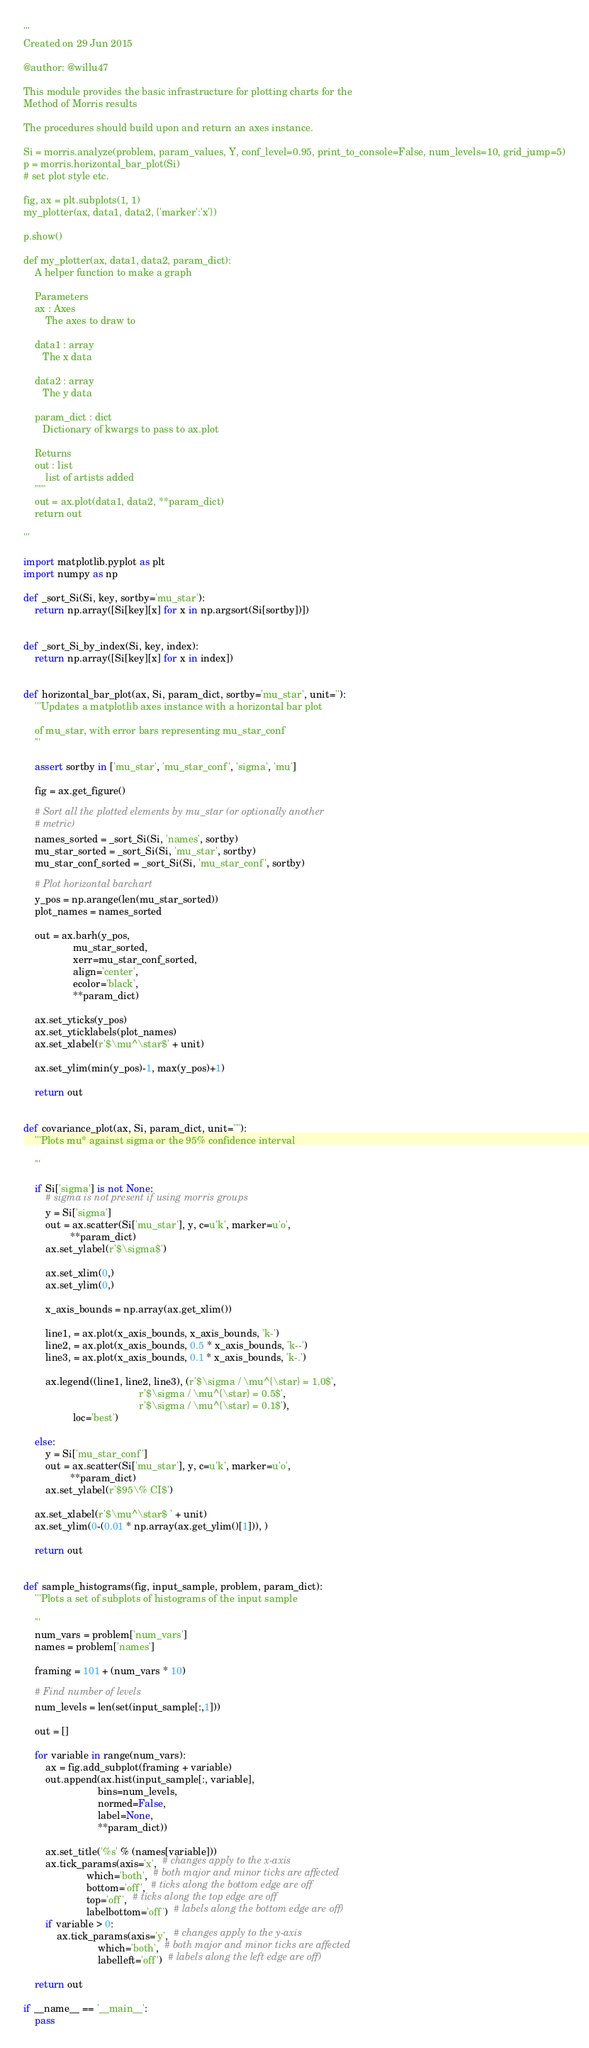Convert code to text. <code><loc_0><loc_0><loc_500><loc_500><_Python_>'''
Created on 29 Jun 2015

@author: @willu47

This module provides the basic infrastructure for plotting charts for the
Method of Morris results

The procedures should build upon and return an axes instance.

Si = morris.analyze(problem, param_values, Y, conf_level=0.95, print_to_console=False, num_levels=10, grid_jump=5)
p = morris.horizontal_bar_plot(Si)
# set plot style etc.

fig, ax = plt.subplots(1, 1)
my_plotter(ax, data1, data2, {'marker':'x'})

p.show()

def my_plotter(ax, data1, data2, param_dict):
    A helper function to make a graph

    Parameters
    ax : Axes
        The axes to draw to

    data1 : array
       The x data

    data2 : array
       The y data

    param_dict : dict
       Dictionary of kwargs to pass to ax.plot

    Returns
    out : list
        list of artists added
    """
    out = ax.plot(data1, data2, **param_dict)
    return out

'''

import matplotlib.pyplot as plt
import numpy as np

def _sort_Si(Si, key, sortby='mu_star'):
    return np.array([Si[key][x] for x in np.argsort(Si[sortby])])


def _sort_Si_by_index(Si, key, index):
    return np.array([Si[key][x] for x in index])


def horizontal_bar_plot(ax, Si, param_dict, sortby='mu_star', unit=''):
    '''Updates a matplotlib axes instance with a horizontal bar plot

    of mu_star, with error bars representing mu_star_conf
    '''

    assert sortby in ['mu_star', 'mu_star_conf', 'sigma', 'mu']

    fig = ax.get_figure()

    # Sort all the plotted elements by mu_star (or optionally another
    # metric)
    names_sorted = _sort_Si(Si, 'names', sortby)
    mu_star_sorted = _sort_Si(Si, 'mu_star', sortby)
    mu_star_conf_sorted = _sort_Si(Si, 'mu_star_conf', sortby)

    # Plot horizontal barchart
    y_pos = np.arange(len(mu_star_sorted))
    plot_names = names_sorted

    out = ax.barh(y_pos,
                  mu_star_sorted,
                  xerr=mu_star_conf_sorted,
                  align='center',
                  ecolor='black',
                  **param_dict)

    ax.set_yticks(y_pos)
    ax.set_yticklabels(plot_names)
    ax.set_xlabel(r'$\mu^\star$' + unit)

    ax.set_ylim(min(y_pos)-1, max(y_pos)+1)

    return out


def covariance_plot(ax, Si, param_dict, unit=""):
    '''Plots mu* against sigma or the 95% confidence interval

    '''

    if Si['sigma'] is not None:
        # sigma is not present if using morris groups
        y = Si['sigma']
        out = ax.scatter(Si['mu_star'], y, c=u'k', marker=u'o',
                 **param_dict)
        ax.set_ylabel(r'$\sigma$')

        ax.set_xlim(0,)
        ax.set_ylim(0,)

        x_axis_bounds = np.array(ax.get_xlim())

        line1, = ax.plot(x_axis_bounds, x_axis_bounds, 'k-')
        line2, = ax.plot(x_axis_bounds, 0.5 * x_axis_bounds, 'k--')
        line3, = ax.plot(x_axis_bounds, 0.1 * x_axis_bounds, 'k-.')

        ax.legend((line1, line2, line3), (r'$\sigma / \mu^{\star} = 1.0$',
                                          r'$\sigma / \mu^{\star} = 0.5$',
                                          r'$\sigma / \mu^{\star} = 0.1$'),
                  loc='best')

    else:
        y = Si['mu_star_conf']
        out = ax.scatter(Si['mu_star'], y, c=u'k', marker=u'o',
                 **param_dict)
        ax.set_ylabel(r'$95\% CI$')

    ax.set_xlabel(r'$\mu^\star$ ' + unit)
    ax.set_ylim(0-(0.01 * np.array(ax.get_ylim()[1])), )

    return out


def sample_histograms(fig, input_sample, problem, param_dict):
    '''Plots a set of subplots of histograms of the input sample

    '''
    num_vars = problem['num_vars']
    names = problem['names']

    framing = 101 + (num_vars * 10)

    # Find number of levels
    num_levels = len(set(input_sample[:,1]))

    out = []

    for variable in range(num_vars):
        ax = fig.add_subplot(framing + variable)
        out.append(ax.hist(input_sample[:, variable],
                           bins=num_levels,
                           normed=False,
                           label=None,
                           **param_dict))

        ax.set_title('%s' % (names[variable]))
        ax.tick_params(axis='x',  # changes apply to the x-axis
                       which='both',  # both major and minor ticks are affected
                       bottom='off',  # ticks along the bottom edge are off
                       top='off',  # ticks along the top edge are off
                       labelbottom='off')  # labels along the bottom edge are off)
        if variable > 0:
            ax.tick_params(axis='y',  # changes apply to the y-axis
                           which='both',  # both major and minor ticks are affected
                           labelleft='off')  # labels along the left edge are off)

    return out

if __name__ == '__main__':
    pass
</code> 